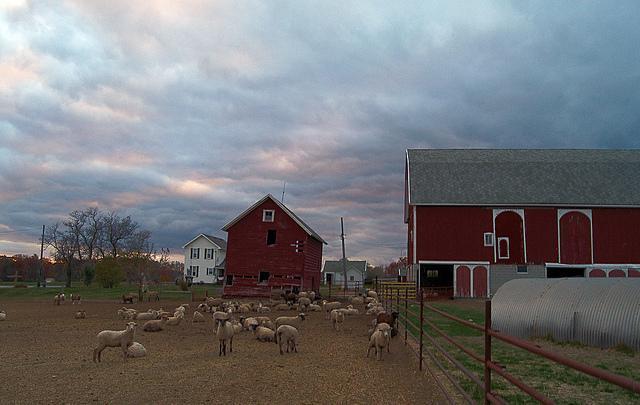How many barns can be seen?
Give a very brief answer. 2. 